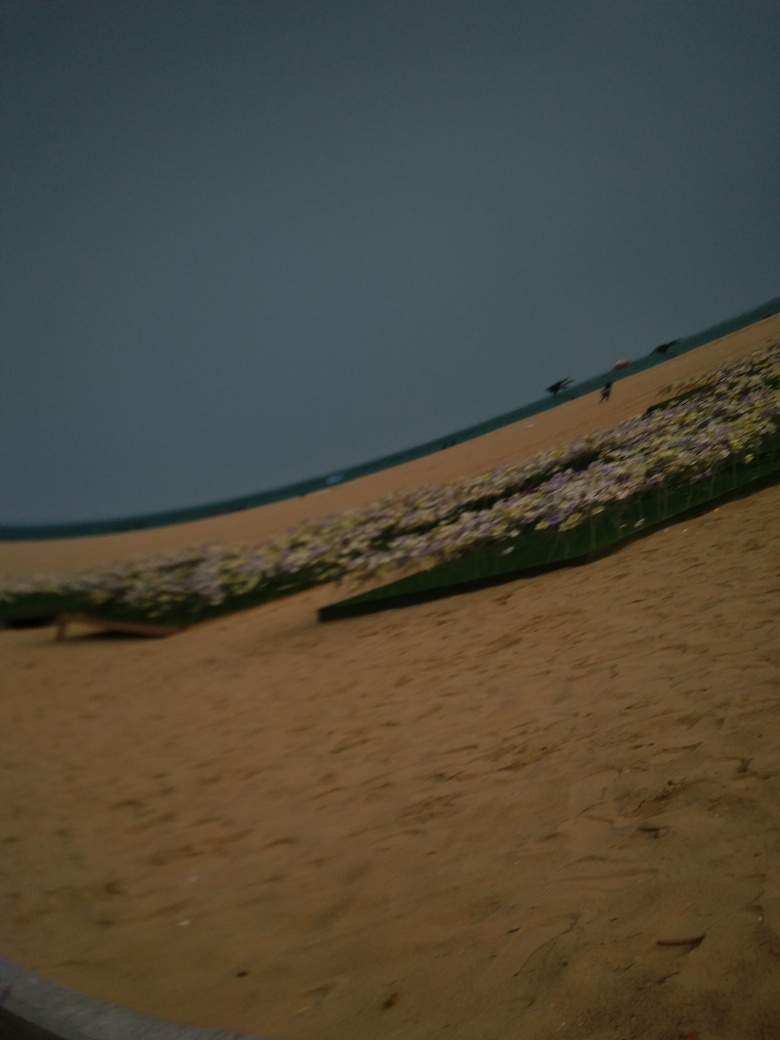What time of day does this image seem to depict? Given the low lighting and the absence of distinct shadows, it appears to be either dusk or dawn, times when the light is typically softer and more diffused. However, it's difficult to determine the exact time of day due to the blurriness and lack of visible sun position in the sky. 